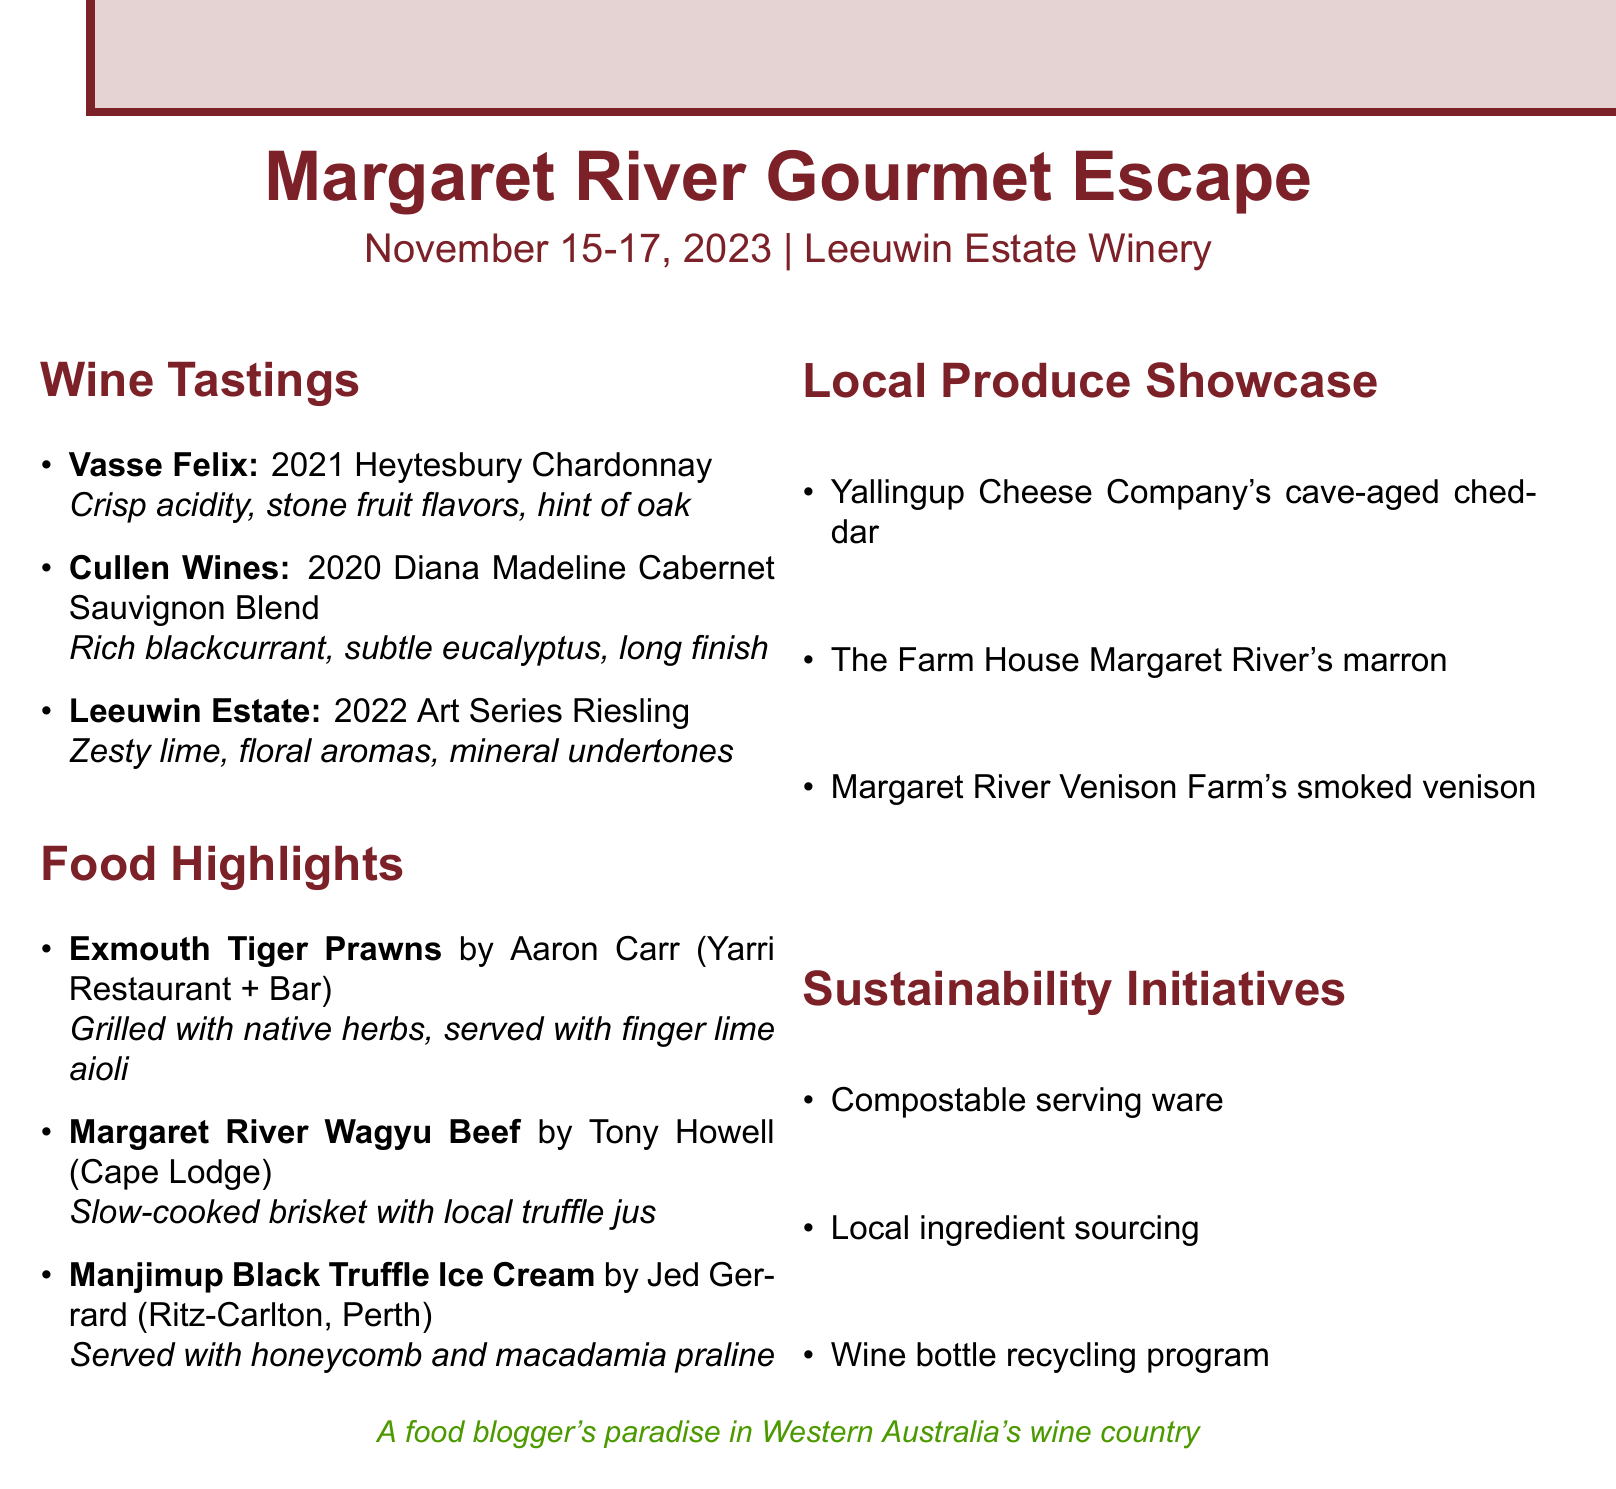What is the name of the event? The event is explicitly titled in the document as "Margaret River Gourmet Escape."
Answer: Margaret River Gourmet Escape When does the event take place? The date is clearly stated as "November 15-17, 2023."
Answer: November 15-17, 2023 Which winery produced the 2021 Heytesbury Chardonnay? The winery associated with the mentioned Chardonnay is specified as "Vasse Felix."
Answer: Vasse Felix What dish is served with finger lime aioli? The dish featuring finger lime aioli is listed in the food highlights section.
Answer: Exmouth Tiger Prawns Who is the chef for the dish "Margaret River Wagyu Beef"? The document identifies "Tony Howell" as the chef for this dish.
Answer: Tony Howell What sustainability initiative involves serving ware? The document mentions one of the sustainability initiatives related to serving ware.
Answer: Compostable serving ware What is one of the local produce highlights? Local produce is detailed in the document, and options are listed.
Answer: Yallingup Cheese Company's cave-aged cheddar What is the highlight of the dessert mentioned? The dessert in focus is described in the food highlights, with its key component noted.
Answer: Manjimup Black Truffle Ice Cream What type of wine is the 2020 Diana Madeline? The type of wine is clearly identified in the tasting notes section.
Answer: Cabernet Sauvignon Blend 